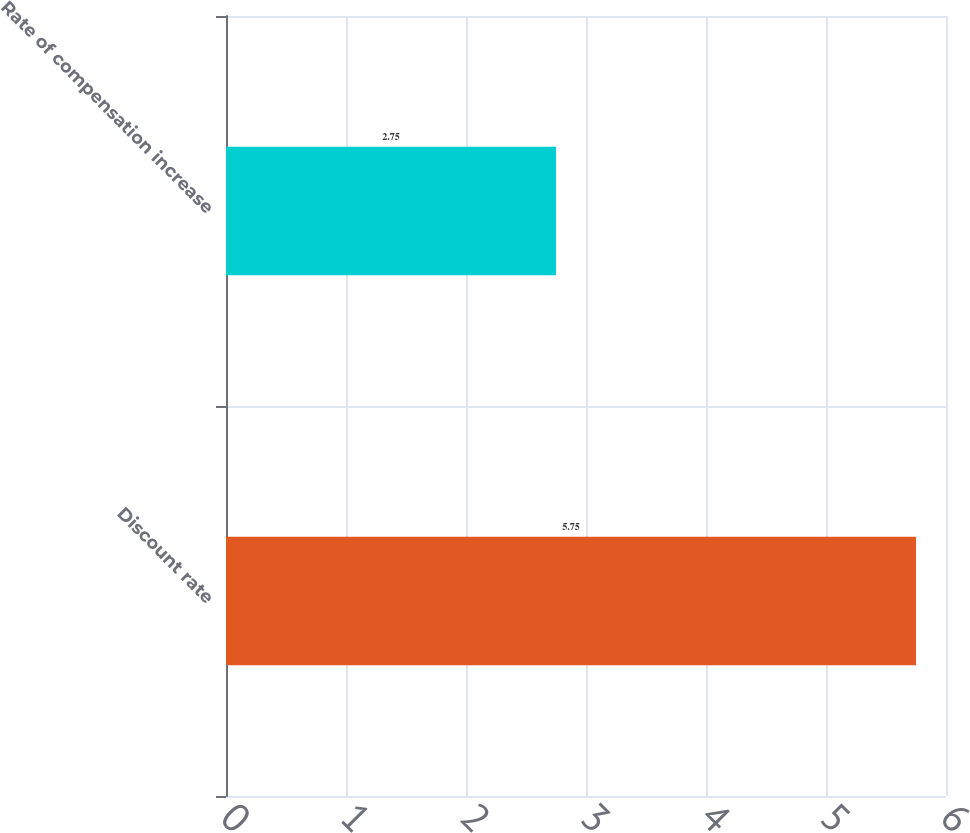Convert chart. <chart><loc_0><loc_0><loc_500><loc_500><bar_chart><fcel>Discount rate<fcel>Rate of compensation increase<nl><fcel>5.75<fcel>2.75<nl></chart> 